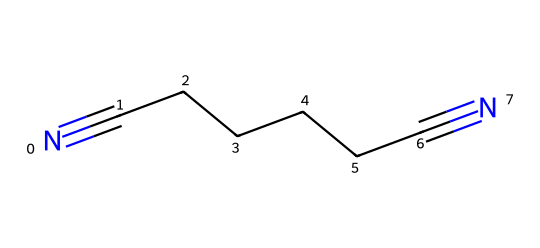What is the name of this compound? The SMILES representation "N#CCCCCC#N" corresponds to a compound with two cyano (nitrile) groups at each end of a six-carbon chain, which is commonly known as adiponitrile.
Answer: adiponitrile How many carbon atoms are in the structure? Counting the carbon atoms in the six-carbon chain (C6) that connects the two nitrile groups gives a total of 6 carbon atoms.
Answer: 6 What type of functional groups are present in this compound? The structure contains two nitrile (–C≡N) functional groups at both ends of the carbon chain, which are characteristic of nitriles.
Answer: nitriles What is the total number of nitrogen atoms in the structure? There are two nitrile functional groups shown in the SMILES, each containing one nitrogen atom, hence the total count is 2 nitrogen atoms.
Answer: 2 What is the number of triple bonds in the chemical? The two cyano groups (–C≡N) indicate that there are two triple bonds in the structure, one for each nitrile group.
Answer: 2 What type of polymer can be made from this chemical? Adiponitrile is a crucial monomer used in the synthesis of nylon-66, which is a type of polyamide polymer.
Answer: nylon-66 What is the primary application of adiponitrile in industry? Adiponitrile is primarily used in the production of nylon, particularly in the manufacturing of fibers and plastics for various applications.
Answer: nylon production 